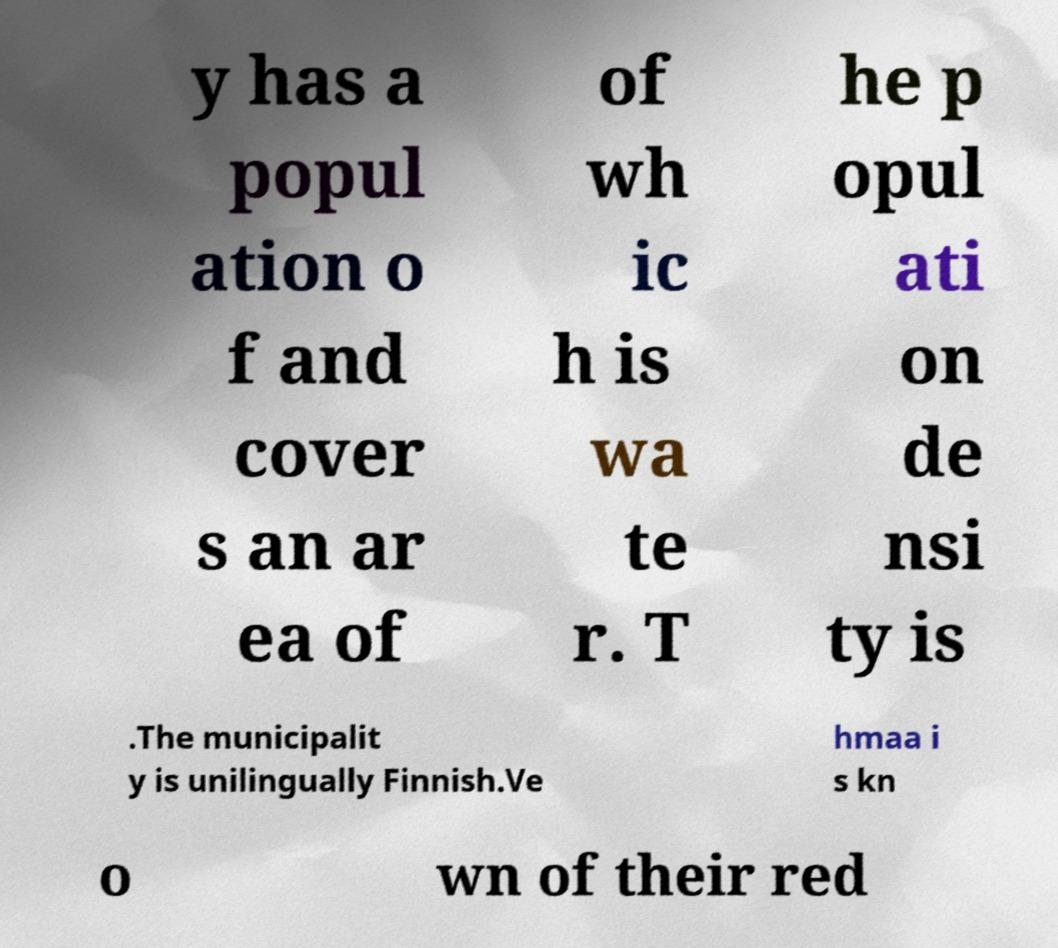Please identify and transcribe the text found in this image. y has a popul ation o f and cover s an ar ea of of wh ic h is wa te r. T he p opul ati on de nsi ty is .The municipalit y is unilingually Finnish.Ve hmaa i s kn o wn of their red 